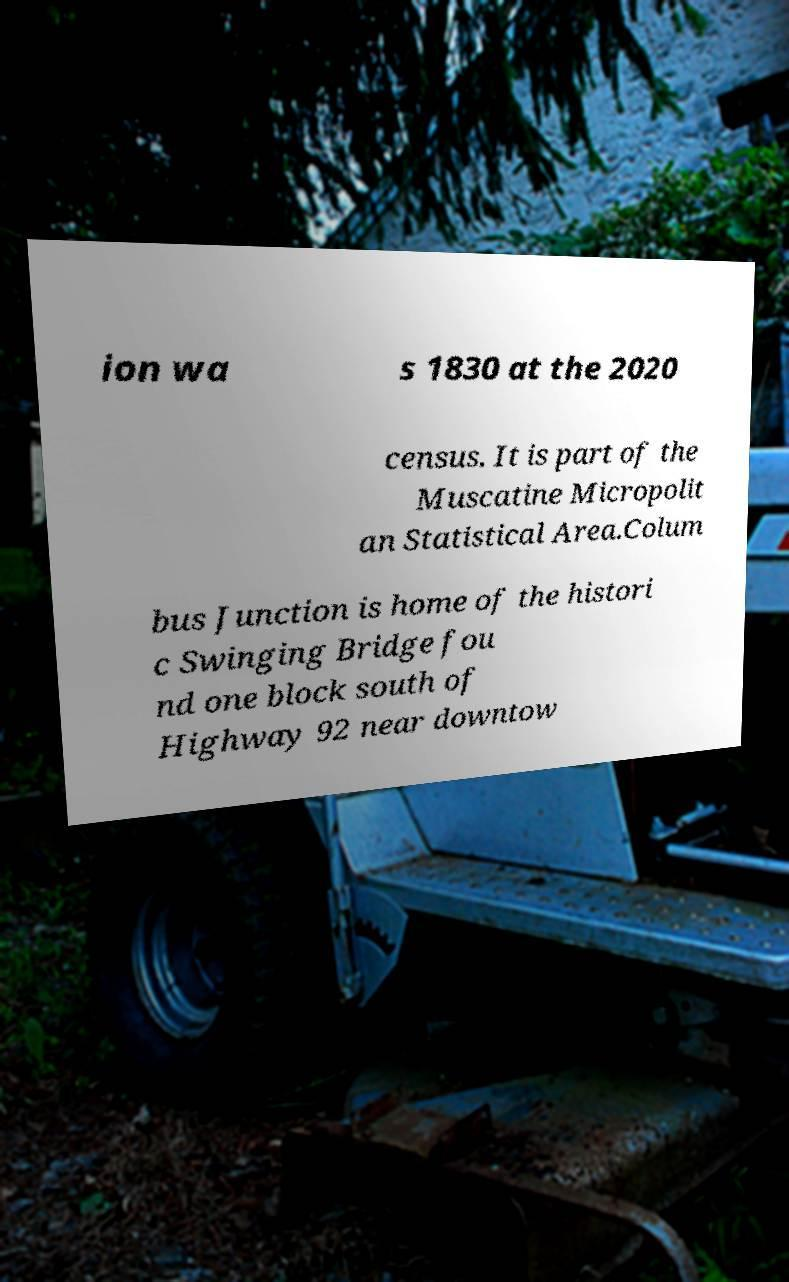Could you extract and type out the text from this image? ion wa s 1830 at the 2020 census. It is part of the Muscatine Micropolit an Statistical Area.Colum bus Junction is home of the histori c Swinging Bridge fou nd one block south of Highway 92 near downtow 